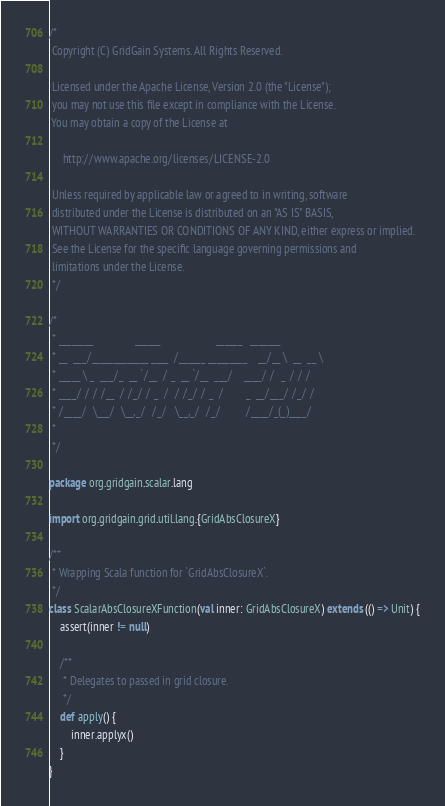<code> <loc_0><loc_0><loc_500><loc_500><_Scala_>/* 
 Copyright (C) GridGain Systems. All Rights Reserved.
 
 Licensed under the Apache License, Version 2.0 (the "License");
 you may not use this file except in compliance with the License.
 You may obtain a copy of the License at

     http://www.apache.org/licenses/LICENSE-2.0
 
 Unless required by applicable law or agreed to in writing, software
 distributed under the License is distributed on an "AS IS" BASIS,
 WITHOUT WARRANTIES OR CONDITIONS OF ANY KIND, either express or implied.
 See the License for the specific language governing permissions and
 limitations under the License.
 */

/*
 * ________               ______                    ______   _______
 * __  ___/_____________ ____  /______ _________    __/__ \  __  __ \
 * _____ \ _  ___/_  __ `/__  / _  __ `/__  ___/    ____/ /  _  / / /
 * ____/ / / /__  / /_/ / _  /  / /_/ / _  /        _  __/___/ /_/ /
 * /____/  \___/  \__,_/  /_/   \__,_/  /_/         /____/_(_)____/
 *
 */

package org.gridgain.scalar.lang

import org.gridgain.grid.util.lang.{GridAbsClosureX}

/**
 * Wrapping Scala function for `GridAbsClosureX`.
 */
class ScalarAbsClosureXFunction(val inner: GridAbsClosureX) extends (() => Unit) {
    assert(inner != null)

    /**
     * Delegates to passed in grid closure.
     */
    def apply() {
        inner.applyx()
    }
}
</code> 